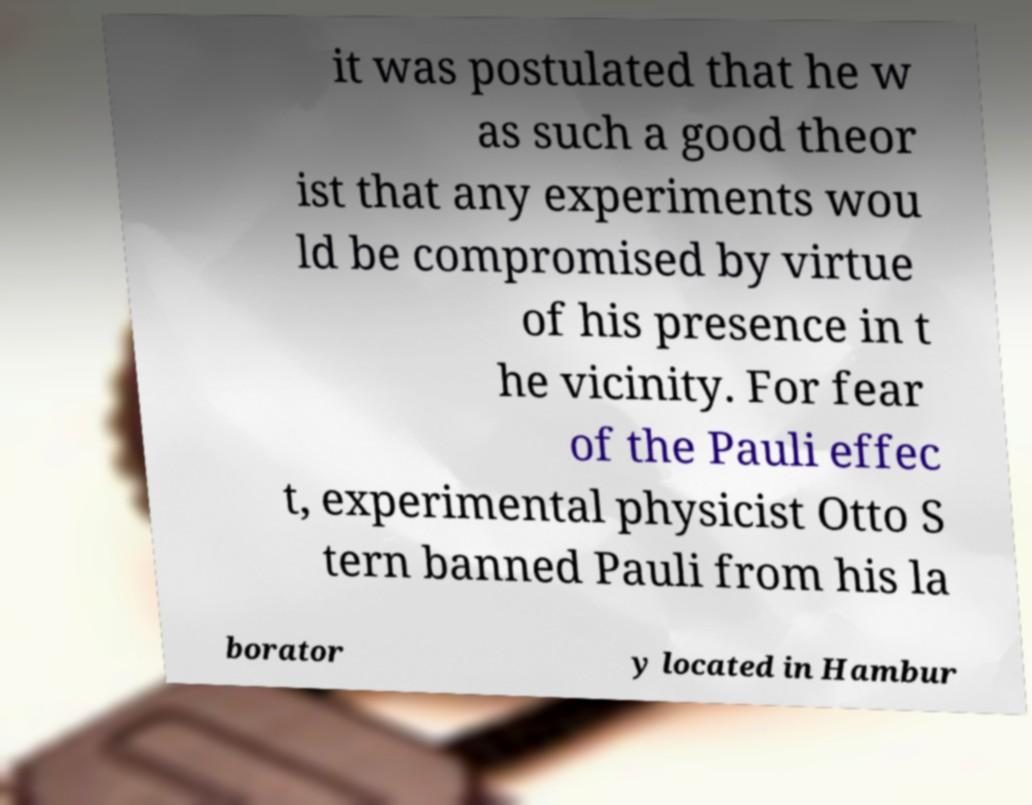Could you extract and type out the text from this image? it was postulated that he w as such a good theor ist that any experiments wou ld be compromised by virtue of his presence in t he vicinity. For fear of the Pauli effec t, experimental physicist Otto S tern banned Pauli from his la borator y located in Hambur 